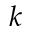Convert formula to latex. <formula><loc_0><loc_0><loc_500><loc_500>k</formula> 